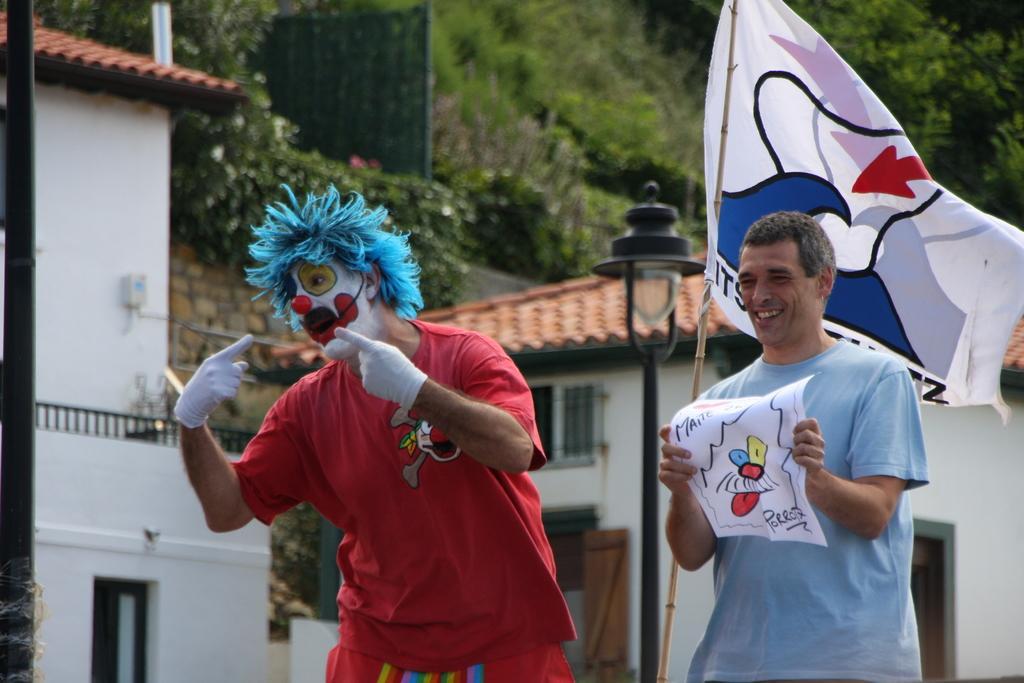How would you summarize this image in a sentence or two? In this picture there is a person with red t-shirt is standing and talking and there is a person with blue t-shirt is standing and smiling and he is holding the paper. At the back there is a flag and there are buildings and trees and there is a pole. On the left side of the image there is a pole. 